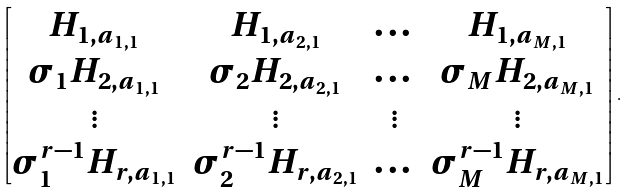<formula> <loc_0><loc_0><loc_500><loc_500>\begin{bmatrix} H _ { 1 , a _ { 1 , 1 } } & H _ { 1 , a _ { 2 , 1 } } & \dots & H _ { 1 , a _ { M , 1 } } \\ \sigma _ { 1 } H _ { 2 , a _ { 1 , 1 } } & \sigma _ { 2 } H _ { 2 , a _ { 2 , 1 } } & \dots & \sigma _ { M } H _ { 2 , a _ { M , 1 } } \\ \vdots & \vdots & \vdots & \vdots \\ \sigma _ { 1 } ^ { r - 1 } H _ { r , a _ { 1 , 1 } } & \sigma _ { 2 } ^ { r - 1 } H _ { r , a _ { 2 , 1 } } & \dots & \sigma _ { M } ^ { r - 1 } H _ { r , a _ { M , 1 } } \end{bmatrix} .</formula> 